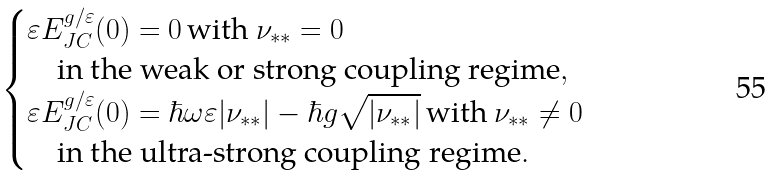Convert formula to latex. <formula><loc_0><loc_0><loc_500><loc_500>\begin{cases} \varepsilon E _ { J C } ^ { g / \varepsilon } ( 0 ) = 0 \, \text {with $\nu_{**}=0$} \\ \quad \text {in the weak or strong coupling regime} , \\ \varepsilon E _ { J C } ^ { g / \varepsilon } ( 0 ) = \hbar { \omega } \varepsilon | \nu _ { * * } | - \hbar { g } \sqrt { | \nu _ { * * } | } \, \text {with $\nu_{**}\ne 0$} \\ \quad \text {in the ultra-strong coupling regime} . \end{cases}</formula> 